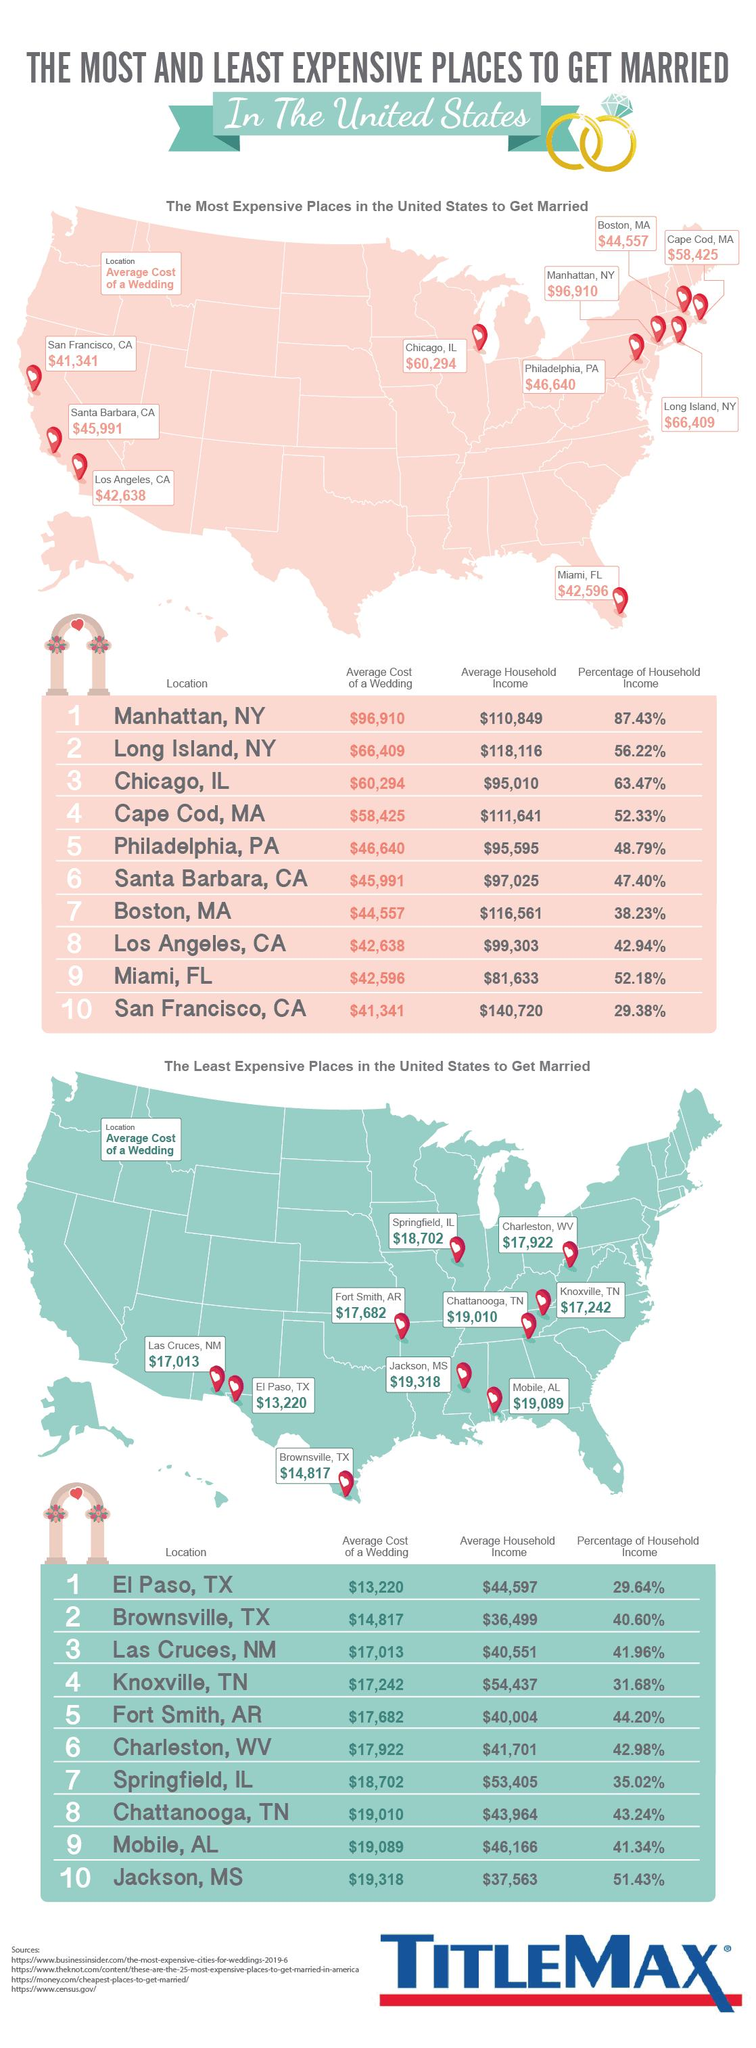Specify some key components in this picture. Chicago, Illinois has the second highest percentage of household income in America. Brownsville, Texas is the second most affordable place in America to get married, with prices lower than many other locations. Long Island, New York is the second most expensive place in America to get married. 